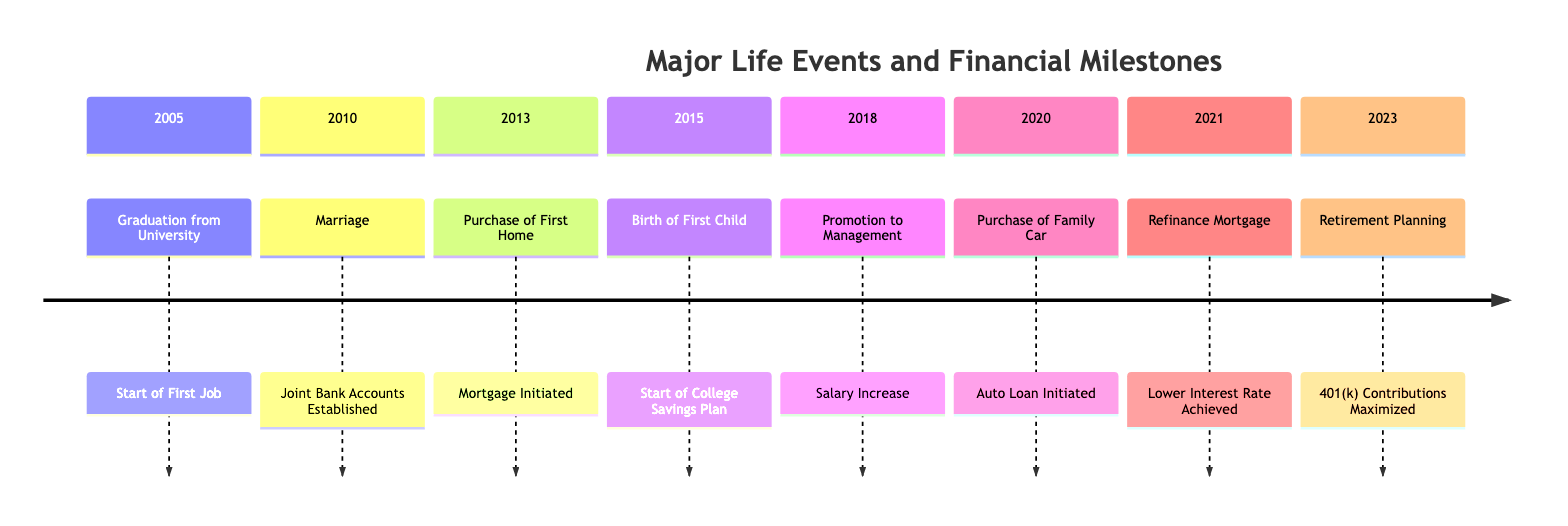What event marks the first milestone in the timeline? The first event in the timeline is "Graduation from University," which occurs in May 2005. This event is associated with the financial milestone "Start of First Job."
Answer: Graduation from University How many financial milestones are listed in the timeline? There are eight financial milestones listed in the timeline, each corresponding to a major life event. They include milestones like "Start of First Job," "Joint Bank Accounts Established," and others up to "401(k) Contributions Maximized."
Answer: 8 What year did the family purchase a home? The family purchased their first home in September 2013, as indicated by the event "Purchase of First Home." This event details the establishment of a mortgage at that time.
Answer: 2013 What financial milestone was achieved when the first child was born? The financial milestone achieved when the first child was born in April 2015 was the "Start of College Savings Plan," specifically a 529 College Savings Plan opened with Northwestern Mutual.
Answer: Start of College Savings Plan Which event occurs immediately after the purchase of the family car? After the "Purchase of Family Car" in May 2020, the next event listed is "Refinance Mortgage" in August 2021. The latter signifies a financial strategy employed after the car purchase.
Answer: Refinance Mortgage In what year did the promotion to management take place? The promotion to management occurred in July 2018. This event is pivotal as it corresponds with a significant salary increase as a financial milestone.
Answer: 2018 Which financial milestone corresponds to the event of marriage? The marriage event in June 2010 corresponds to the financial milestone of establishing "Joint Bank Accounts," indicating a partnership in financial management post-marriage.
Answer: Joint Bank Accounts Established What is the date of the retirement planning start? The retirement planning began in January 2023, marked by the event that shows 401(k) contributions were maximized along with additional retirement savings strategies.
Answer: 2023 